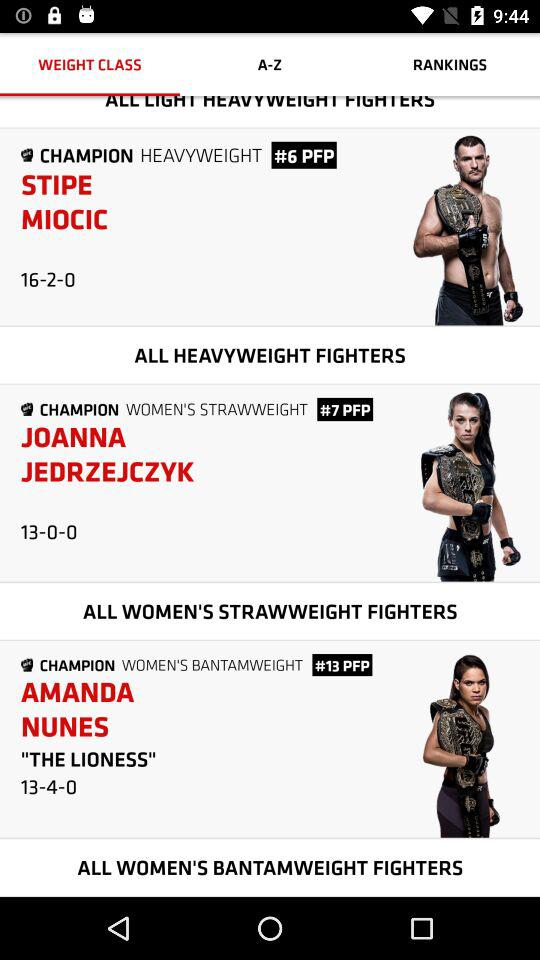Who is Joanna Jedrzejczyk? Joanna Jedrzejczyk is a "WOMEN'S STRAWWEIGHT" champion. 